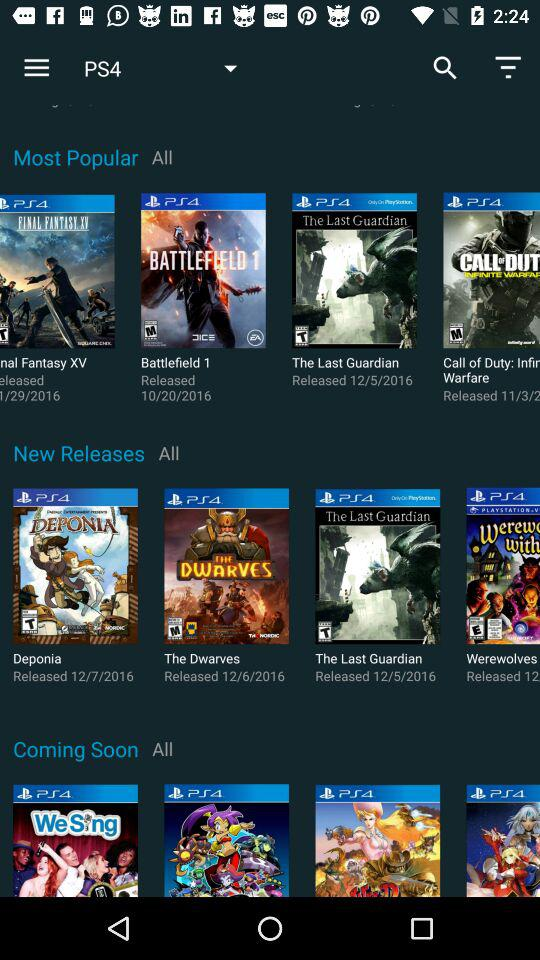What is the release date of "Deponia"? The release date of "Deponia" is December 7, 2016. 